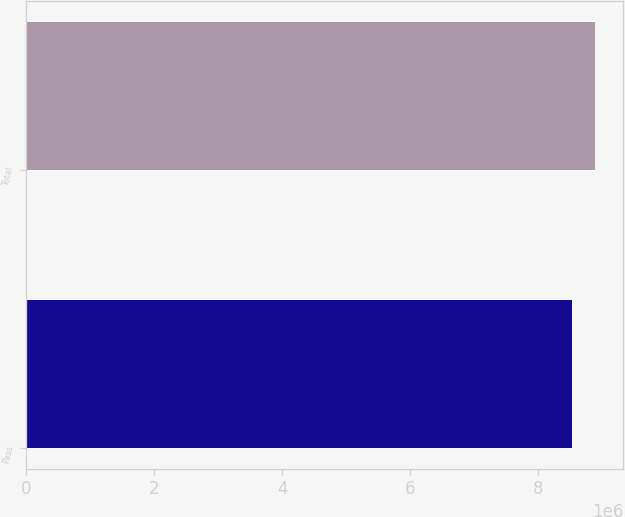<chart> <loc_0><loc_0><loc_500><loc_500><bar_chart><fcel>Pass<fcel>Total<nl><fcel>8.53523e+06<fcel>8.89135e+06<nl></chart> 